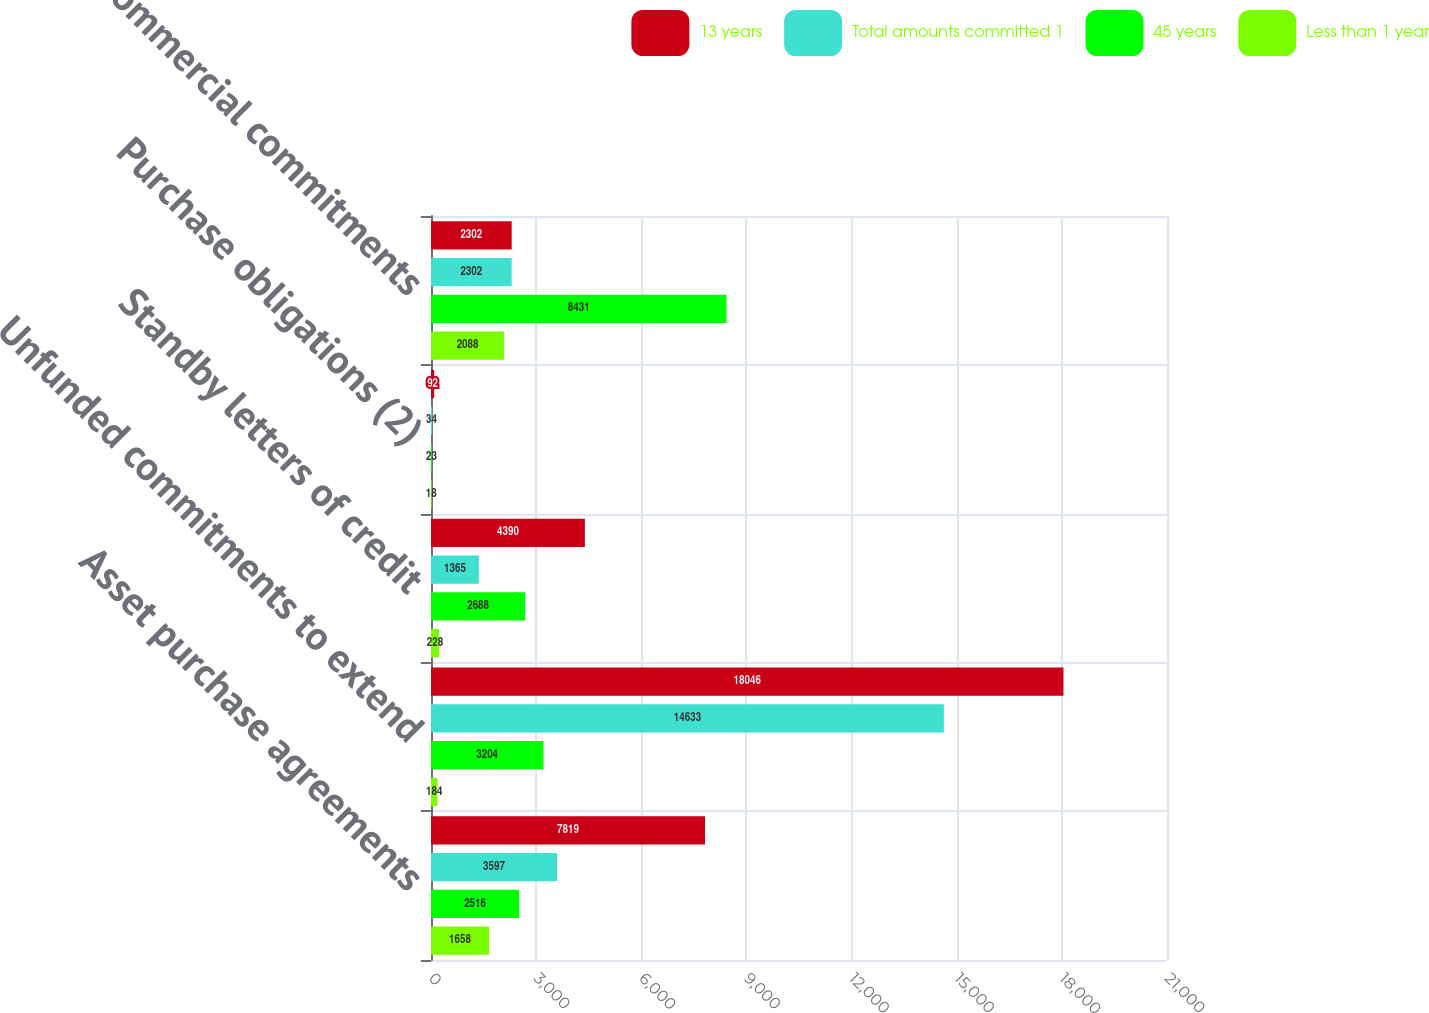Convert chart. <chart><loc_0><loc_0><loc_500><loc_500><stacked_bar_chart><ecel><fcel>Asset purchase agreements<fcel>Unfunded commitments to extend<fcel>Standby letters of credit<fcel>Purchase obligations (2)<fcel>Total commercial commitments<nl><fcel>13 years<fcel>7819<fcel>18046<fcel>4390<fcel>92<fcel>2302<nl><fcel>Total amounts committed 1<fcel>3597<fcel>14633<fcel>1365<fcel>34<fcel>2302<nl><fcel>45 years<fcel>2516<fcel>3204<fcel>2688<fcel>23<fcel>8431<nl><fcel>Less than 1 year<fcel>1658<fcel>184<fcel>228<fcel>18<fcel>2088<nl></chart> 